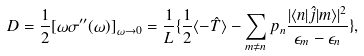Convert formula to latex. <formula><loc_0><loc_0><loc_500><loc_500>D = \frac { 1 } { 2 } [ \omega \sigma ^ { \prime \prime } ( \omega ) ] _ { \omega \to 0 } = \frac { 1 } { L } \{ \frac { 1 } { 2 } \langle - \hat { T } \rangle - \sum _ { m \neq n } p _ { n } \frac { | \langle n | \hat { j } | m \rangle | ^ { 2 } } { \epsilon _ { m } - \epsilon _ { n } } \} ,</formula> 